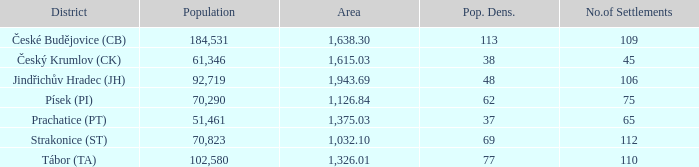In an area of 1,126.84, what is the population size? 70290.0. 